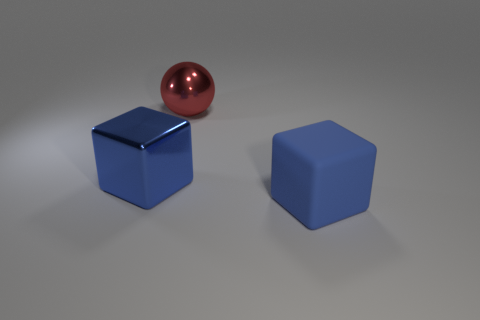The big object that is behind the blue metallic cube has what shape?
Your answer should be compact. Sphere. Does the block to the left of the large red ball have the same color as the big block to the right of the big ball?
Offer a terse response. Yes. There is a object that is the same color as the large metallic block; what is its size?
Your answer should be compact. Large. Is there a tiny red cylinder?
Give a very brief answer. No. The large blue object that is behind the block that is on the right side of the blue block that is behind the blue matte block is what shape?
Provide a short and direct response. Cube. There is a blue metal thing; how many large red balls are left of it?
Your answer should be very brief. 0. Does the blue thing on the right side of the big blue shiny object have the same material as the sphere?
Provide a short and direct response. No. How many other objects are there of the same shape as the large matte object?
Ensure brevity in your answer.  1. There is a red sphere behind the big blue block right of the red shiny ball; how many large red metal balls are left of it?
Provide a succinct answer. 0. What is the color of the block that is on the left side of the blue matte block?
Provide a short and direct response. Blue. 